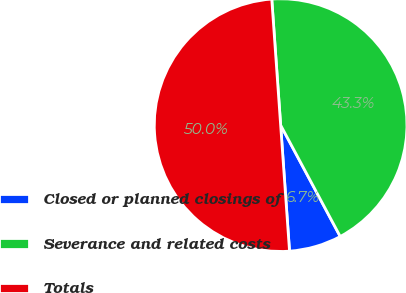Convert chart to OTSL. <chart><loc_0><loc_0><loc_500><loc_500><pie_chart><fcel>Closed or planned closings of<fcel>Severance and related costs<fcel>Totals<nl><fcel>6.7%<fcel>43.3%<fcel>50.0%<nl></chart> 